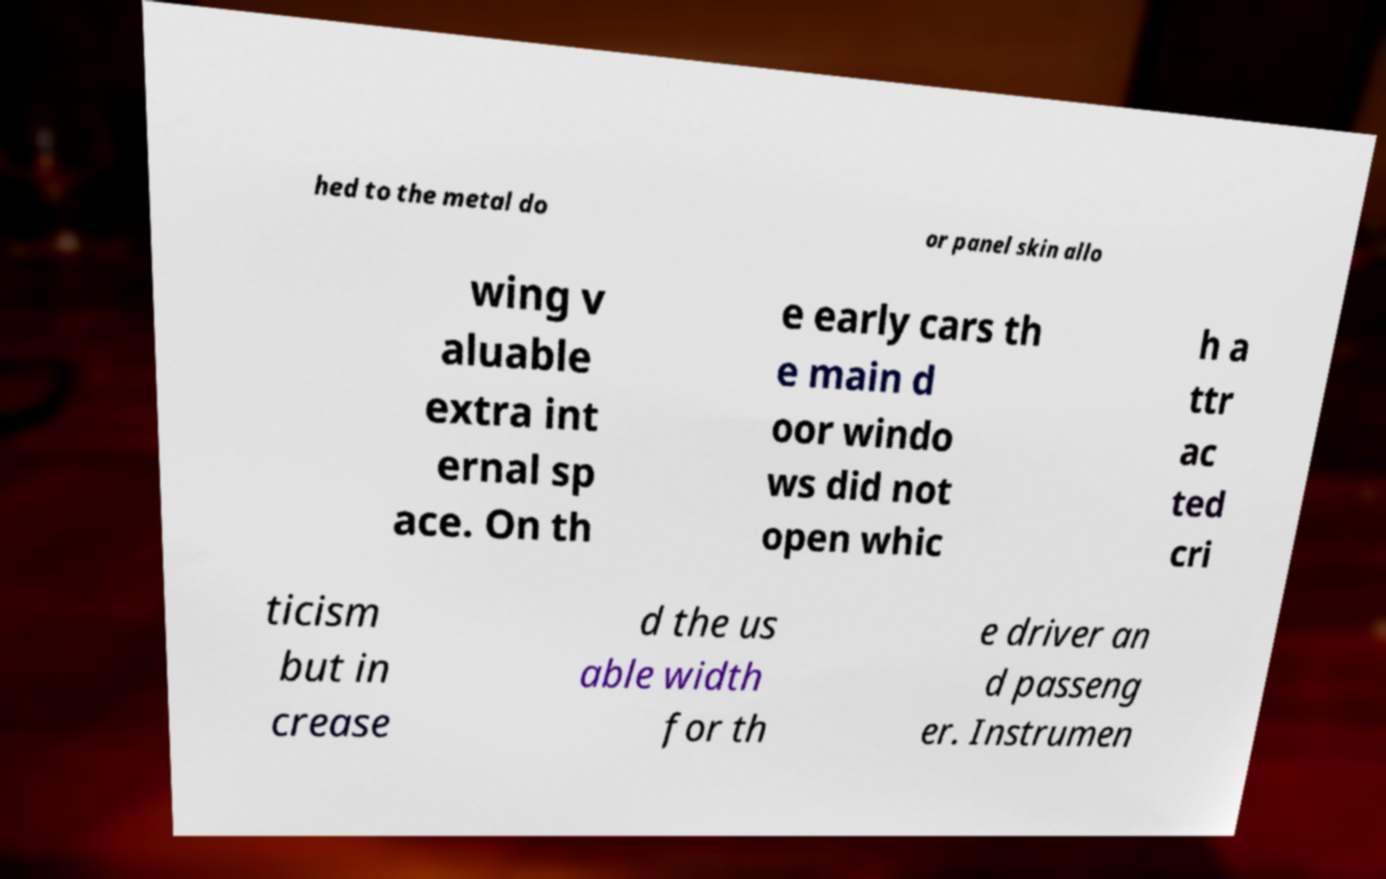There's text embedded in this image that I need extracted. Can you transcribe it verbatim? hed to the metal do or panel skin allo wing v aluable extra int ernal sp ace. On th e early cars th e main d oor windo ws did not open whic h a ttr ac ted cri ticism but in crease d the us able width for th e driver an d passeng er. Instrumen 